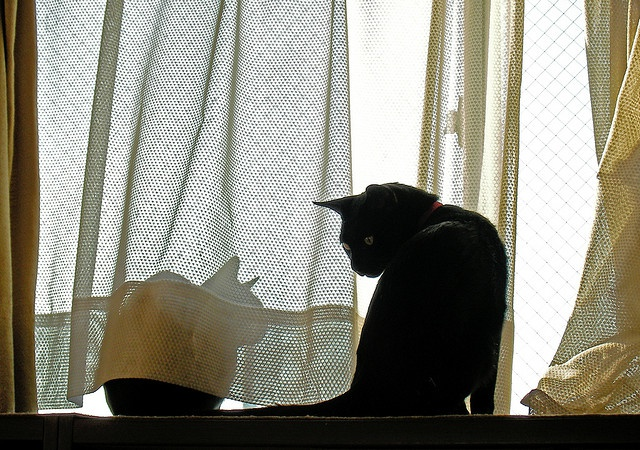Describe the objects in this image and their specific colors. I can see cat in black, gray, white, and tan tones and cat in black, olive, gray, and maroon tones in this image. 